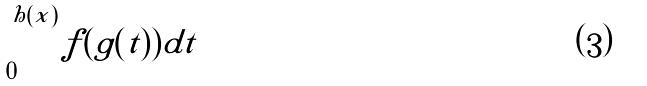<formula> <loc_0><loc_0><loc_500><loc_500>\int _ { 0 } ^ { h ( x ) } f ( g ( t ) ) d t</formula> 